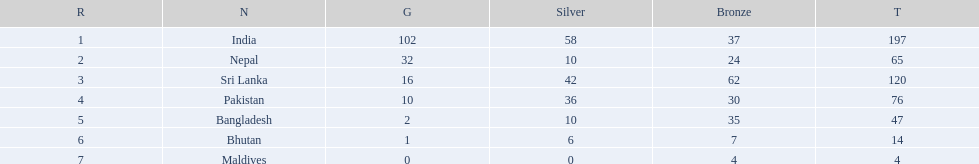What countries attended the 1999 south asian games? India, Nepal, Sri Lanka, Pakistan, Bangladesh, Bhutan, Maldives. Which of these countries had 32 gold medals? Nepal. 